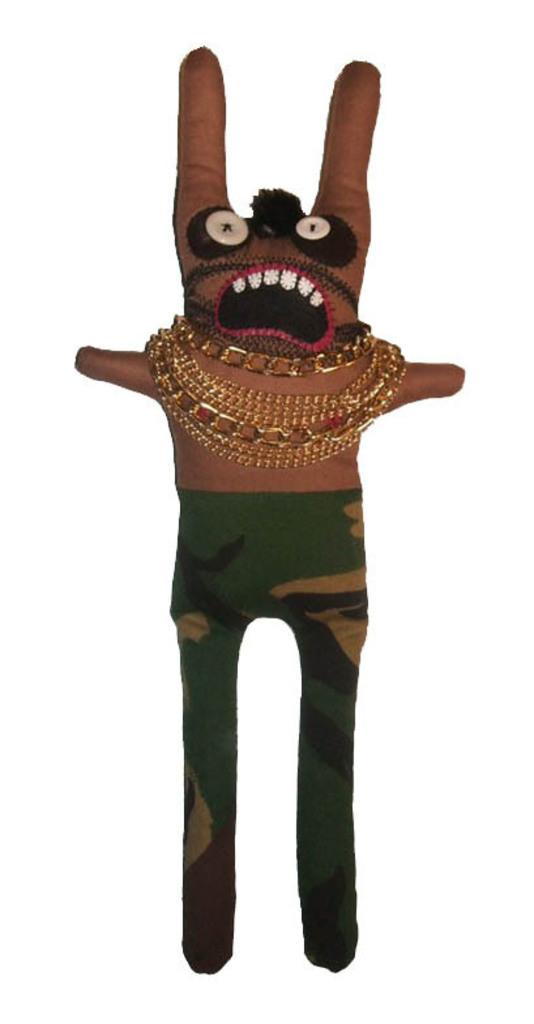What is the main subject of the picture? The main subject of the picture is a doll. Can you describe the color of the doll? The doll is brown in color. What type of clothing is the doll wearing? The doll is wearing green-colored trousers with designs. Are there any accessories on the doll? Yes, the doll has gold chains. What type of stem can be seen growing from the doll's head in the image? There is no stem growing from the doll's head in the image. What color is the orange that the doll is holding in the image? There is no orange present in the image. 